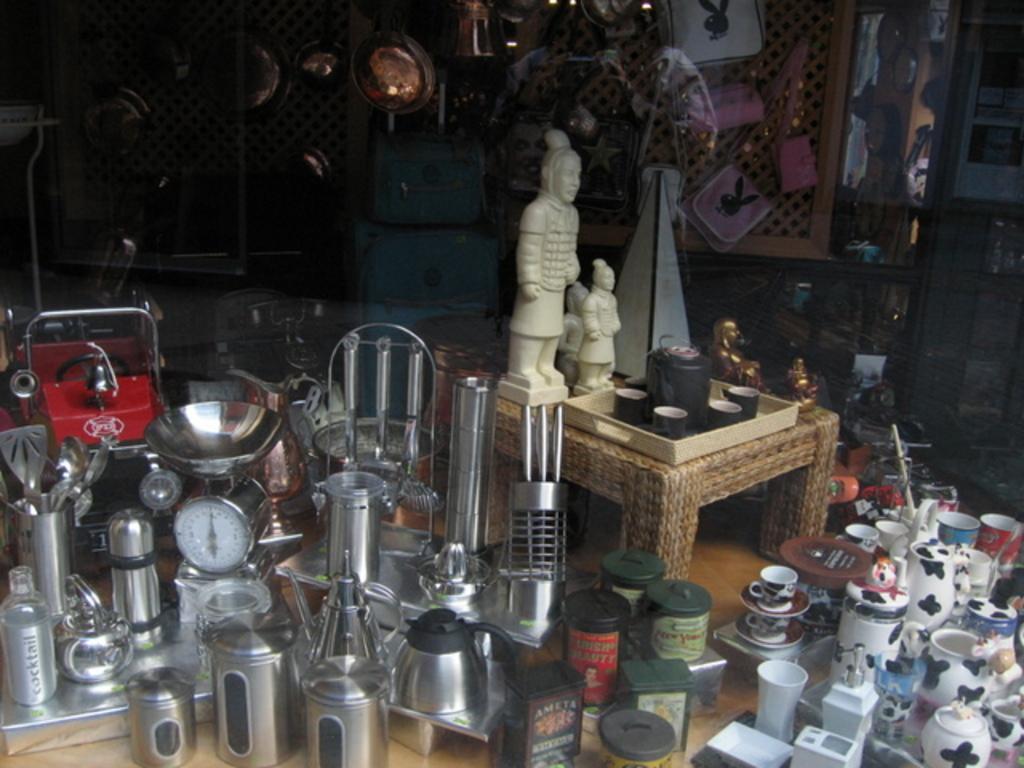How would you summarize this image in a sentence or two? At the bottom of the image I can see bowls, jars, boxers, glasses, cups, saucers and many objects are placed on the floor. On the right side, I can see a small table on which a tray, two statues and few glasses are placed. In the background few bags and few bowls are hanging to a net and also I can see a bag. 